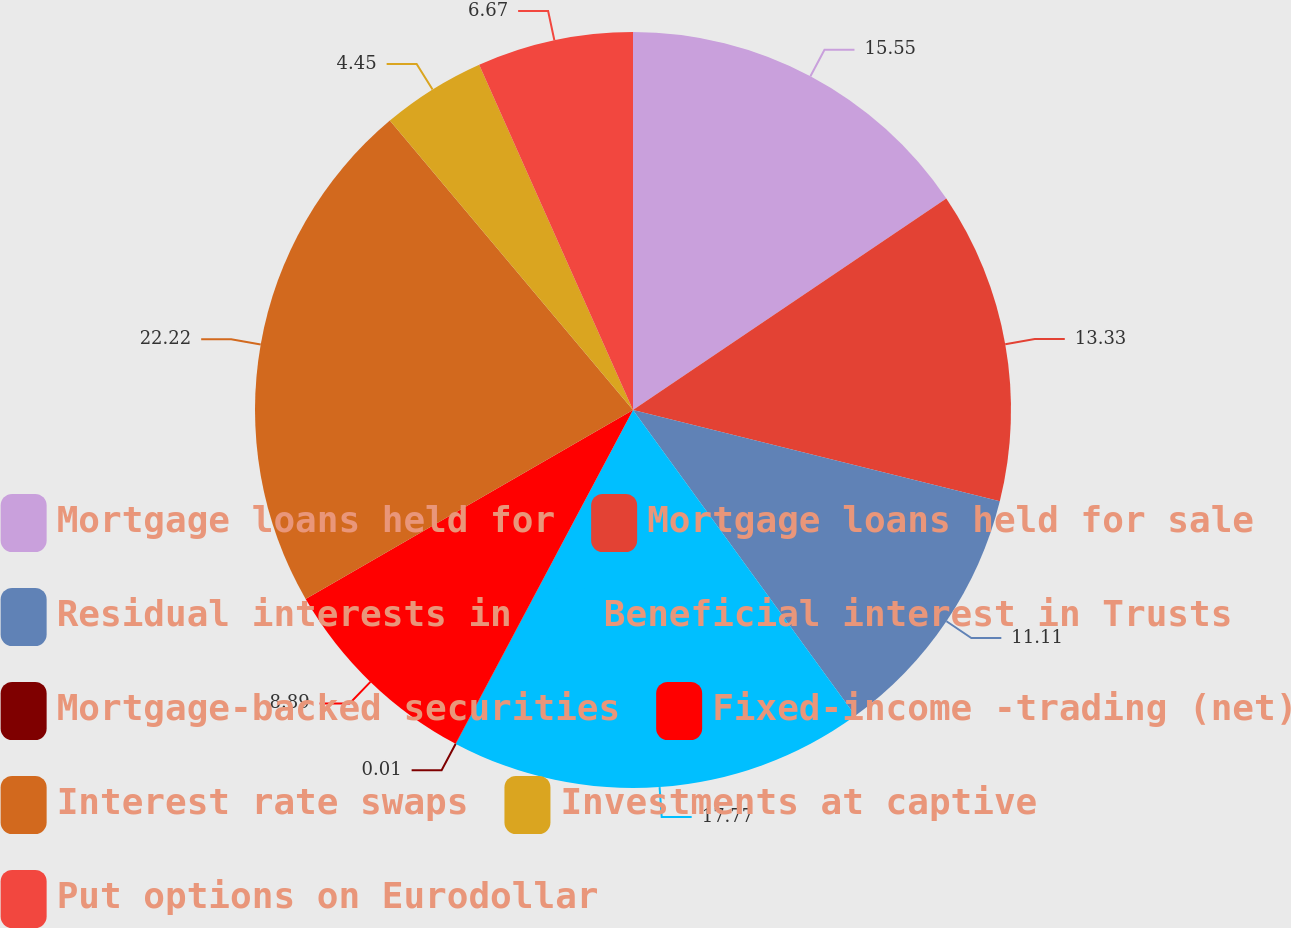<chart> <loc_0><loc_0><loc_500><loc_500><pie_chart><fcel>Mortgage loans held for<fcel>Mortgage loans held for sale<fcel>Residual interests in<fcel>Beneficial interest in Trusts<fcel>Mortgage-backed securities<fcel>Fixed-income -trading (net)<fcel>Interest rate swaps<fcel>Investments at captive<fcel>Put options on Eurodollar<nl><fcel>15.55%<fcel>13.33%<fcel>11.11%<fcel>17.77%<fcel>0.01%<fcel>8.89%<fcel>22.21%<fcel>4.45%<fcel>6.67%<nl></chart> 